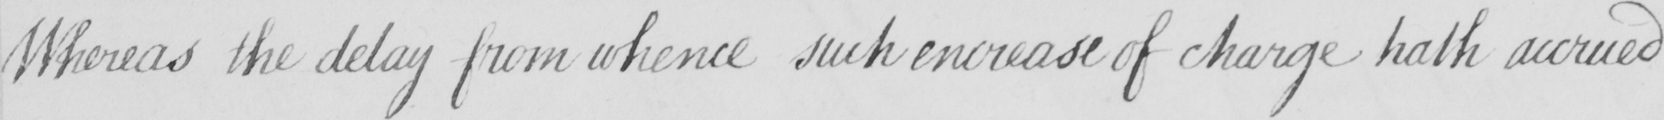What text is written in this handwritten line? Whereas the delay from whence such encrease of charge hath accrued 